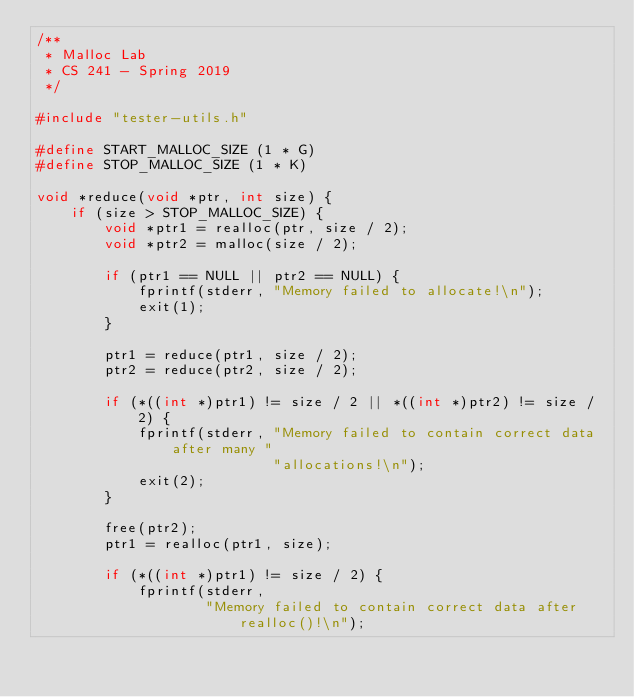<code> <loc_0><loc_0><loc_500><loc_500><_C_>/**
 * Malloc Lab
 * CS 241 - Spring 2019
 */
 
#include "tester-utils.h"

#define START_MALLOC_SIZE (1 * G)
#define STOP_MALLOC_SIZE (1 * K) 

void *reduce(void *ptr, int size) {
    if (size > STOP_MALLOC_SIZE) {
        void *ptr1 = realloc(ptr, size / 2);
        void *ptr2 = malloc(size / 2);

        if (ptr1 == NULL || ptr2 == NULL) {
            fprintf(stderr, "Memory failed to allocate!\n");
            exit(1);
        }

        ptr1 = reduce(ptr1, size / 2);
        ptr2 = reduce(ptr2, size / 2);

        if (*((int *)ptr1) != size / 2 || *((int *)ptr2) != size / 2) {
            fprintf(stderr, "Memory failed to contain correct data after many "
                            "allocations!\n");
            exit(2);
        }

        free(ptr2);
        ptr1 = realloc(ptr1, size);

        if (*((int *)ptr1) != size / 2) {
            fprintf(stderr,
                    "Memory failed to contain correct data after realloc()!\n");</code> 